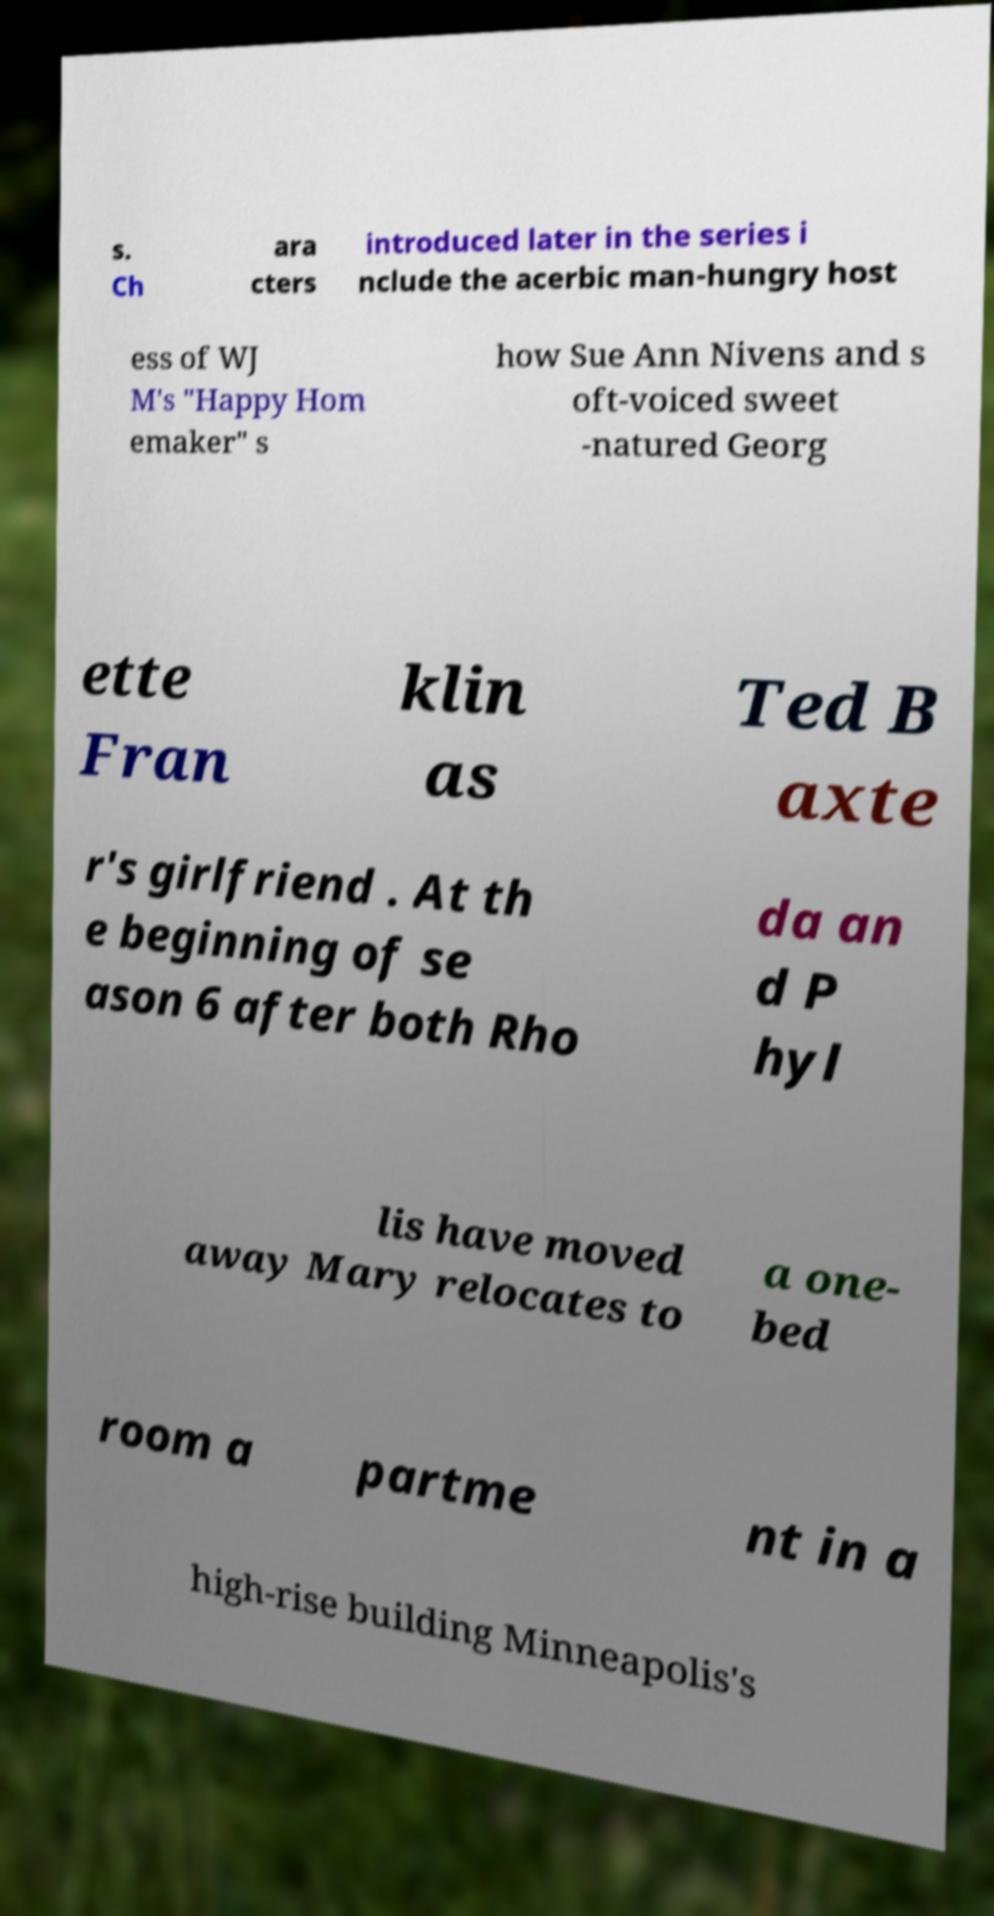What messages or text are displayed in this image? I need them in a readable, typed format. s. Ch ara cters introduced later in the series i nclude the acerbic man-hungry host ess of WJ M's "Happy Hom emaker" s how Sue Ann Nivens and s oft-voiced sweet -natured Georg ette Fran klin as Ted B axte r's girlfriend . At th e beginning of se ason 6 after both Rho da an d P hyl lis have moved away Mary relocates to a one- bed room a partme nt in a high-rise building Minneapolis's 